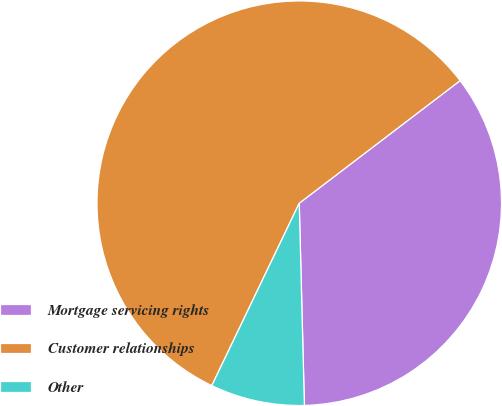Convert chart. <chart><loc_0><loc_0><loc_500><loc_500><pie_chart><fcel>Mortgage servicing rights<fcel>Customer relationships<fcel>Other<nl><fcel>34.96%<fcel>57.52%<fcel>7.52%<nl></chart> 